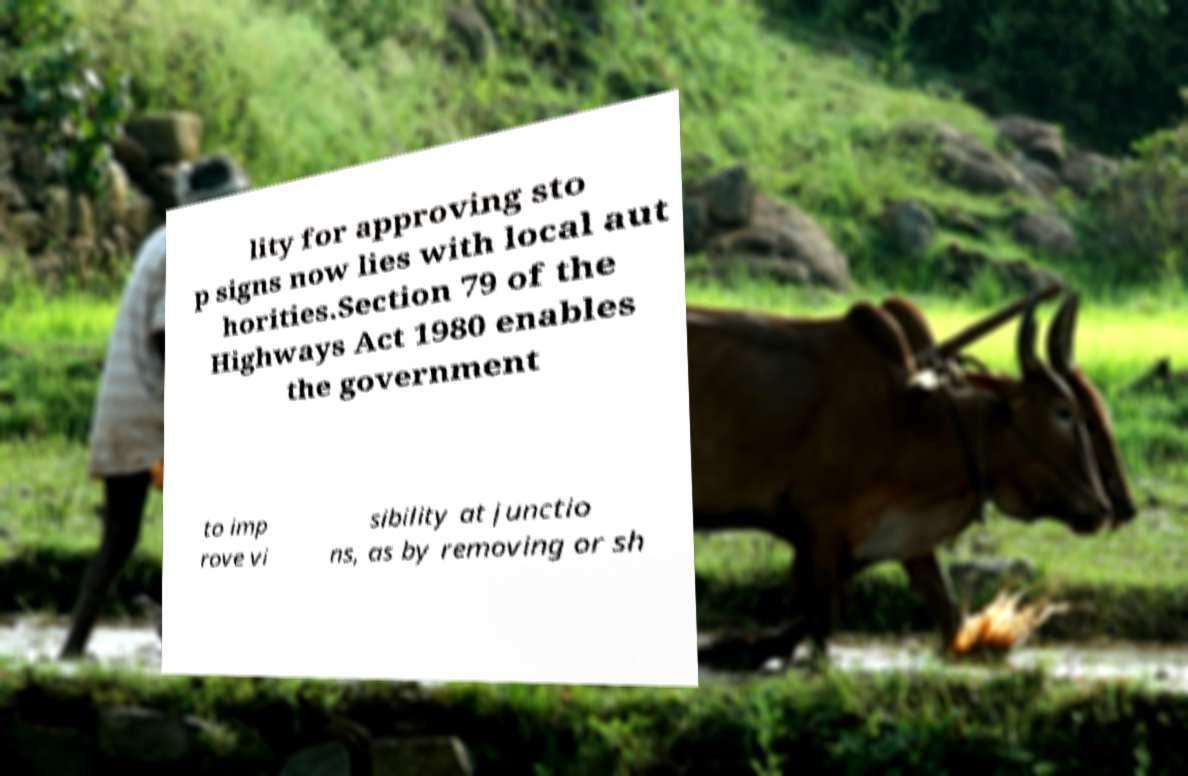I need the written content from this picture converted into text. Can you do that? lity for approving sto p signs now lies with local aut horities.Section 79 of the Highways Act 1980 enables the government to imp rove vi sibility at junctio ns, as by removing or sh 